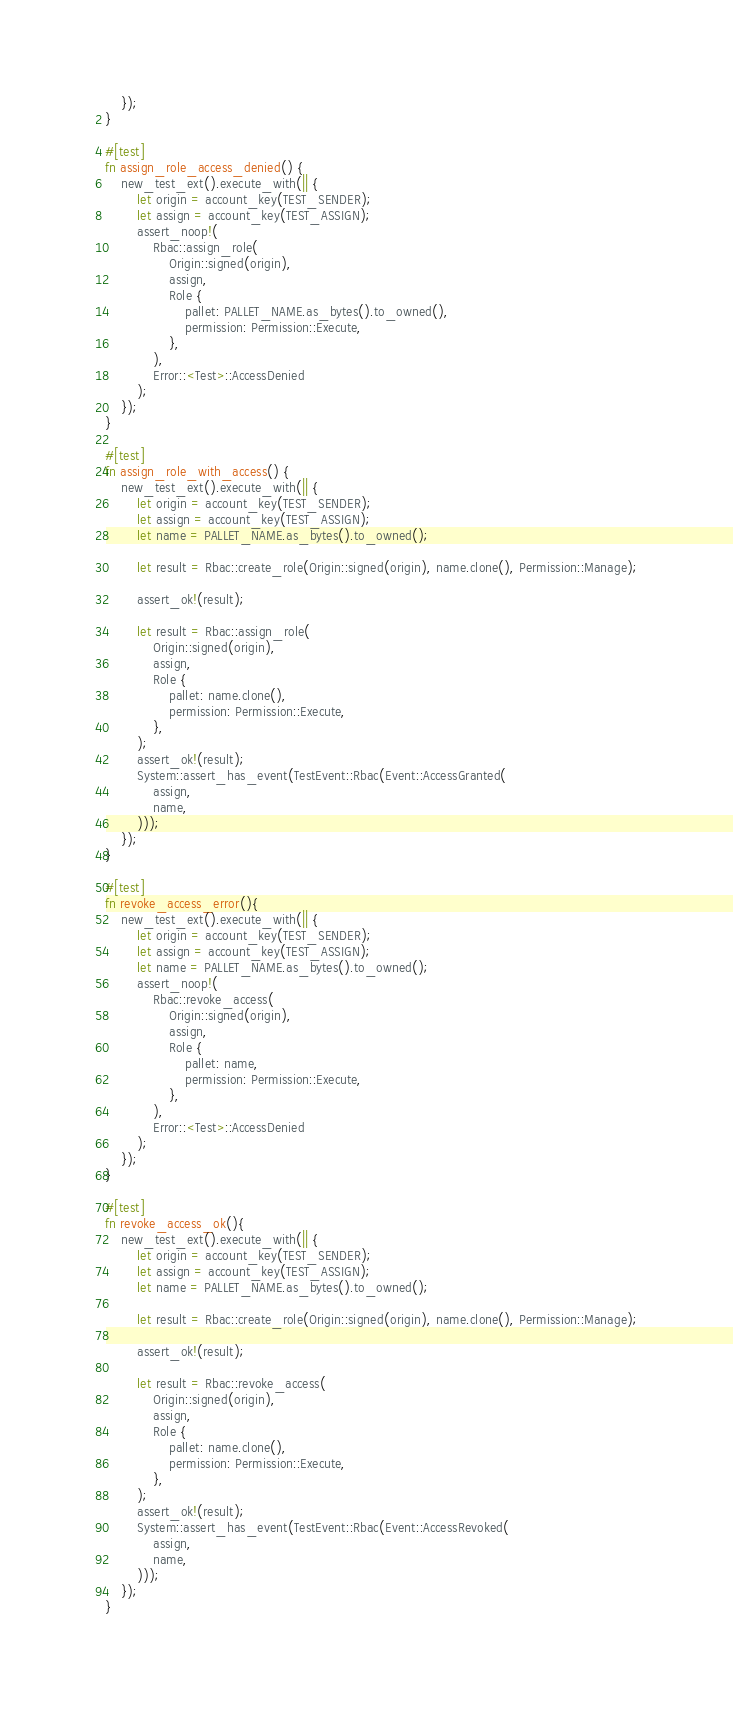<code> <loc_0><loc_0><loc_500><loc_500><_Rust_>    });
}

#[test]
fn assign_role_access_denied() {
    new_test_ext().execute_with(|| {
        let origin = account_key(TEST_SENDER);
        let assign = account_key(TEST_ASSIGN);
        assert_noop!(
            Rbac::assign_role(
                Origin::signed(origin),
                assign,
                Role {
                    pallet: PALLET_NAME.as_bytes().to_owned(),
                    permission: Permission::Execute,
                },
            ),
            Error::<Test>::AccessDenied
        );
    });
}

#[test]
fn assign_role_with_access() {
    new_test_ext().execute_with(|| {
        let origin = account_key(TEST_SENDER);
        let assign = account_key(TEST_ASSIGN);
        let name = PALLET_NAME.as_bytes().to_owned();

        let result = Rbac::create_role(Origin::signed(origin), name.clone(), Permission::Manage);

        assert_ok!(result);

        let result = Rbac::assign_role(
            Origin::signed(origin),
            assign,
            Role {
                pallet: name.clone(),
                permission: Permission::Execute,
            },
        );
        assert_ok!(result);
        System::assert_has_event(TestEvent::Rbac(Event::AccessGranted(
            assign,
            name,
        )));
    });
}

#[test]
fn revoke_access_error(){
    new_test_ext().execute_with(|| {
        let origin = account_key(TEST_SENDER);
        let assign = account_key(TEST_ASSIGN);
        let name = PALLET_NAME.as_bytes().to_owned();
        assert_noop!(
            Rbac::revoke_access(
                Origin::signed(origin),
                assign,
                Role {
                    pallet: name,
                    permission: Permission::Execute,
                },
            ),
            Error::<Test>::AccessDenied
        );
    });
}

#[test]
fn revoke_access_ok(){
    new_test_ext().execute_with(|| {
        let origin = account_key(TEST_SENDER);
        let assign = account_key(TEST_ASSIGN);
        let name = PALLET_NAME.as_bytes().to_owned();

        let result = Rbac::create_role(Origin::signed(origin), name.clone(), Permission::Manage);

        assert_ok!(result);

        let result = Rbac::revoke_access(
            Origin::signed(origin),
            assign,
            Role {
                pallet: name.clone(),
                permission: Permission::Execute,
            },
        );
        assert_ok!(result);
        System::assert_has_event(TestEvent::Rbac(Event::AccessRevoked(
            assign,
            name,
        )));
    });
}</code> 